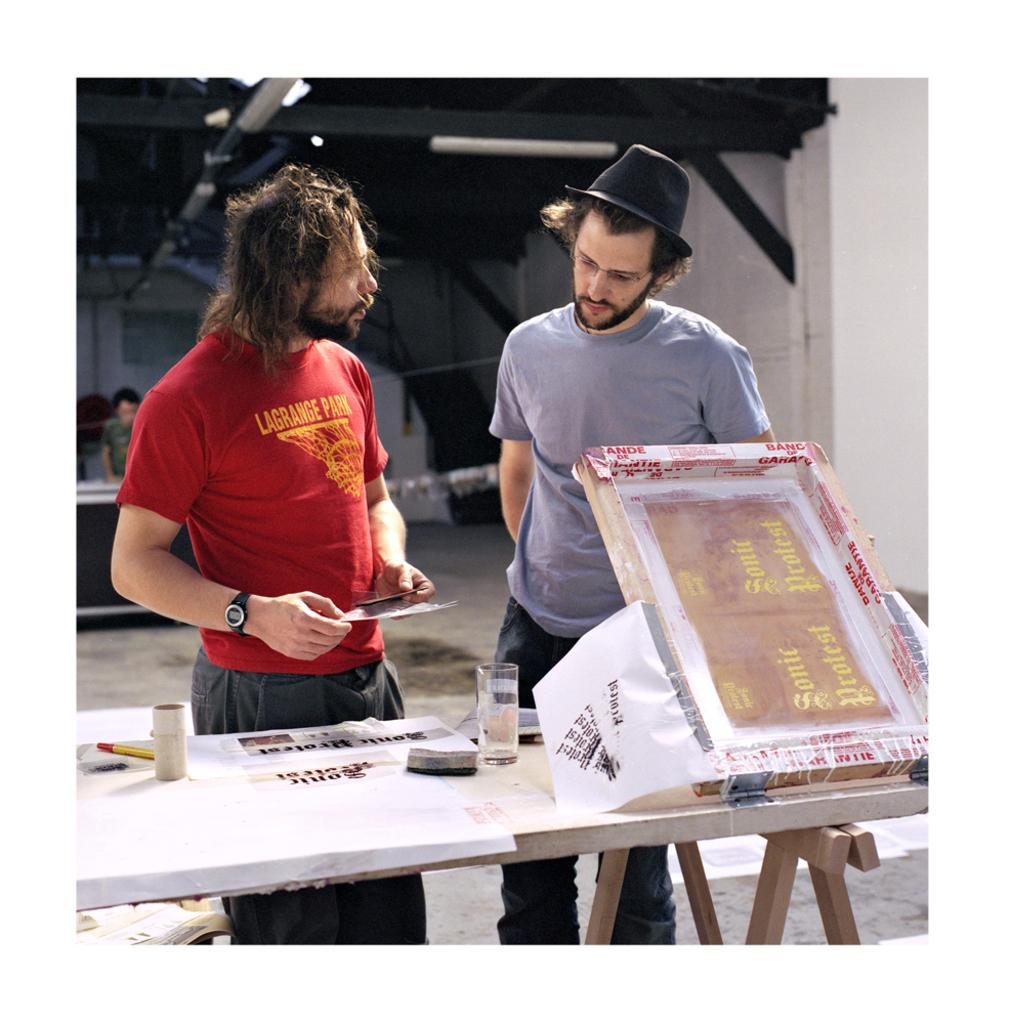What is the person in the image wearing? The person in the image is wearing a red shirt. What is the person holding in the image? The person is holding an object. How many people are in the image? There are two people in the image. What is present in the image besides the people? There is a table in the image. What is on the table in the image? The table has paper and a glass on it. What type of plantation can be seen in the background of the image? There is no plantation visible in the image. What color is the hair of the person in the image? The provided facts do not mention the person's hair color. 